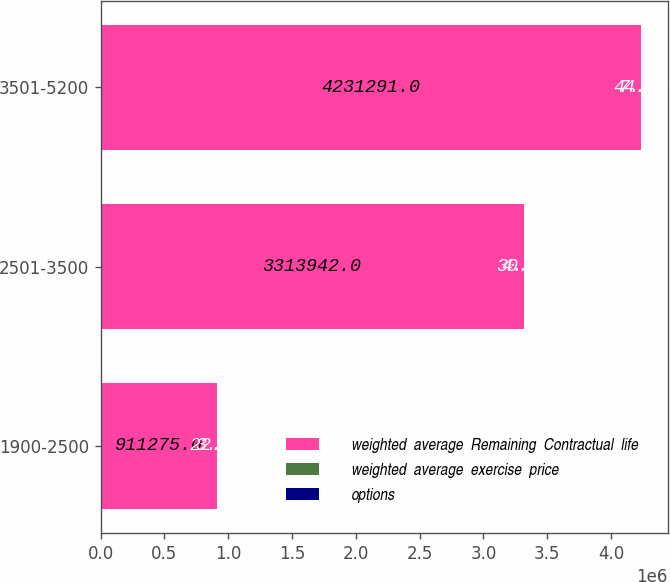Convert chart. <chart><loc_0><loc_0><loc_500><loc_500><stacked_bar_chart><ecel><fcel>1900-2500<fcel>2501-3500<fcel>3501-5200<nl><fcel>weighted  average  Remaining  Contractual  life<fcel>911275<fcel>3.31394e+06<fcel>4.23129e+06<nl><fcel>weighted  average  exercise  price<fcel>3.42<fcel>4.59<fcel>7.14<nl><fcel>options<fcel>22.22<fcel>30.26<fcel>44.09<nl></chart> 